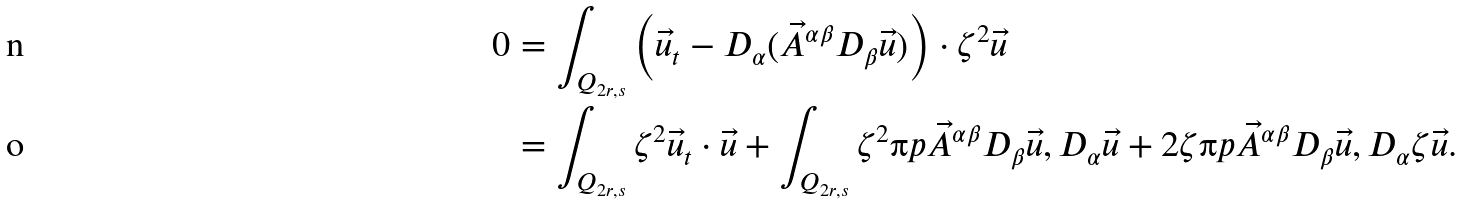<formula> <loc_0><loc_0><loc_500><loc_500>0 & = \int _ { Q _ { 2 r , s } } \left ( \vec { u } _ { t } - D _ { \alpha } ( \vec { A } ^ { \alpha \beta } D _ { \beta } \vec { u } ) \right ) \cdot \zeta ^ { 2 } \vec { u } \\ & = \int _ { Q _ { 2 r , s } } \zeta ^ { 2 } \vec { u } _ { t } \cdot \vec { u } + \int _ { Q _ { 2 r , s } } \zeta ^ { 2 } \i p { \vec { A } ^ { \alpha \beta } D _ { \beta } \vec { u } , D _ { \alpha } \vec { u } } + 2 \zeta \i p { \vec { A } ^ { \alpha \beta } D _ { \beta } \vec { u } , D _ { \alpha } \zeta \vec { u } } .</formula> 